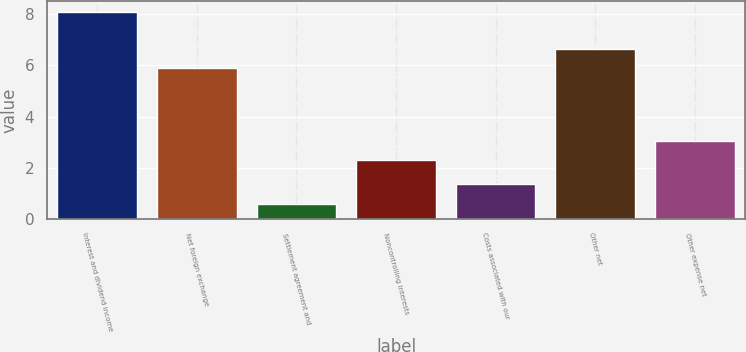<chart> <loc_0><loc_0><loc_500><loc_500><bar_chart><fcel>Interest and dividend income<fcel>Net foreign exchange<fcel>Settlement agreement and<fcel>Noncontrolling interests<fcel>Costs associated with our<fcel>Other net<fcel>Other expense net<nl><fcel>8.1<fcel>5.9<fcel>0.6<fcel>2.3<fcel>1.35<fcel>6.65<fcel>3.05<nl></chart> 